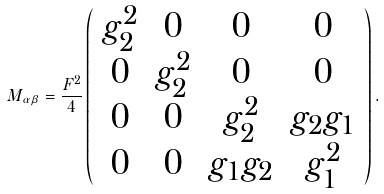Convert formula to latex. <formula><loc_0><loc_0><loc_500><loc_500>M _ { \alpha \beta } = \frac { F ^ { 2 } } { 4 } \left ( \begin{array} { c c c c } g _ { 2 } ^ { 2 } & 0 & 0 & 0 \\ 0 & g _ { 2 } ^ { 2 } & 0 & 0 \\ 0 & 0 & g _ { 2 } ^ { 2 } & g _ { 2 } g _ { 1 } \\ 0 & 0 & g _ { 1 } g _ { 2 } & g _ { 1 } ^ { 2 } \end{array} \right ) .</formula> 